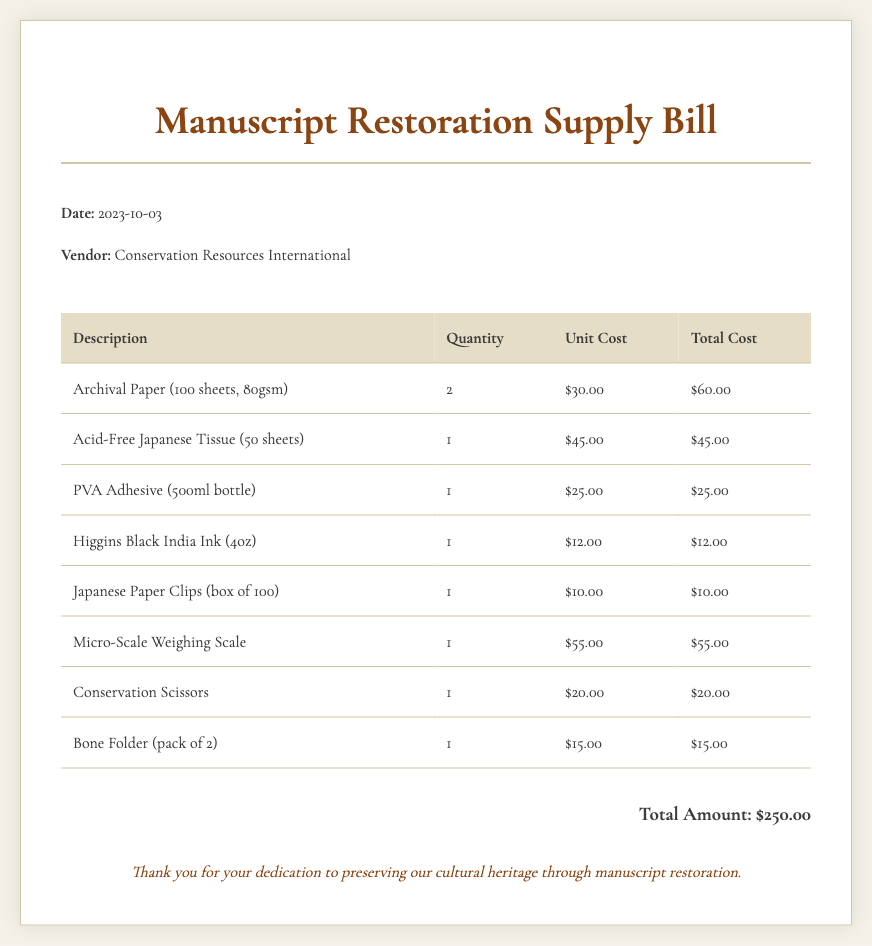What is the date of the bill? The date of the bill is listed at the top of the document, which states "2023-10-03."
Answer: 2023-10-03 Who is the vendor for the supplies? The vendor information is indicated just below the date, which shows "Conservation Resources International."
Answer: Conservation Resources International What is the total amount of the bill? The total amount is summarized at the bottom of the document, shown as "Total Amount: $250.00."
Answer: $250.00 How many sheets of Archival Paper are ordered? The quantity for Archival Paper is given in the table, which shows "2."
Answer: 2 What is the unit cost of PVA Adhesive? The unit cost for PVA Adhesive can be found in the table, which states "$25.00."
Answer: $25.00 What type of adhesive is included in the bill? The document specifies the type of adhesive in the item list, which is "PVA Adhesive."
Answer: PVA Adhesive What item is priced at $20.00? Among the listed items, the "Conservation Scissors" is priced at "$20.00."
Answer: Conservation Scissors How many pieces are there in a box of Japanese Paper Clips? The document states the quantity in a box, which is "100."
Answer: 100 What is the total cost of Acid-Free Japanese Tissue? The total cost for Acid-Free Japanese Tissue is mentioned in the table as "$45.00."
Answer: $45.00 